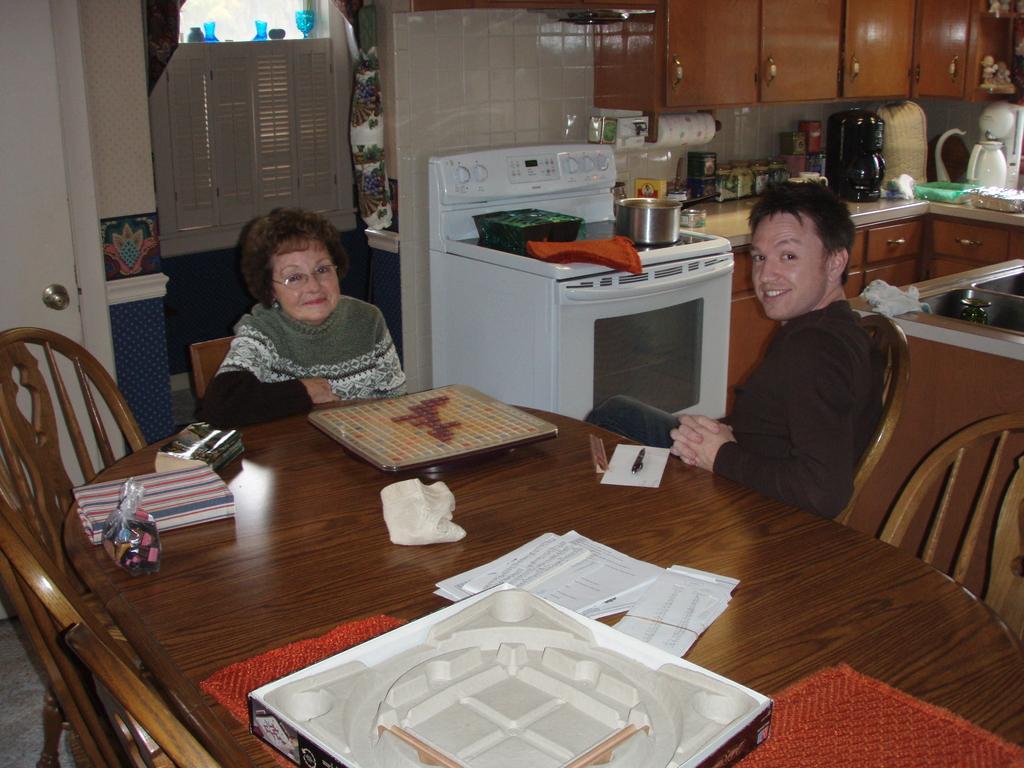Describe this image in one or two sentences. In this image, we can see people sitting on the chairs and we can see boards, papers and some other objects on the table and there are some more chairs. In the background, we can see an oven and there are some jars, vessels, a kettle and some other objects and we can see cupboards, a curtain and some decor items. At the bottom, there is a floor. 